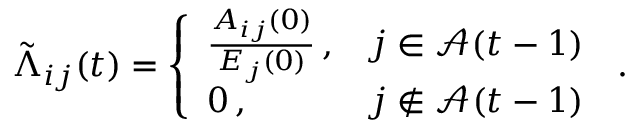Convert formula to latex. <formula><loc_0><loc_0><loc_500><loc_500>\tilde { \Lambda } _ { i j } ( t ) = \left \{ \begin{array} { l l } { \frac { A _ { i j } ( 0 ) } { E _ { j } ( 0 ) } \, , } & { j \in \mathcal { A } ( t - 1 ) } \\ { 0 \, , } & { j \not \in \mathcal { A } ( t - 1 ) } \end{array} \, .</formula> 